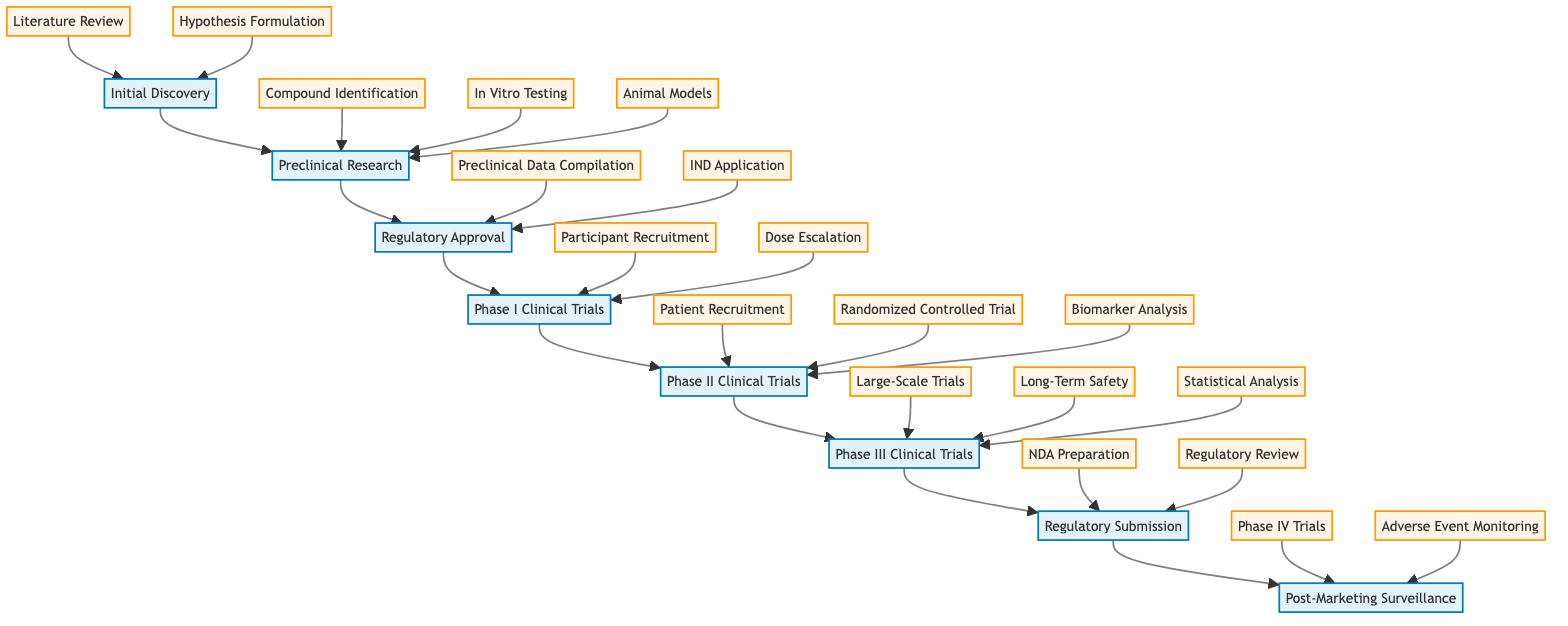What is the first step in the process? The first step indicated in the diagram is "Initial Discovery," which is the beginning of the treatment development process.
Answer: Initial Discovery How many phases are there in the clinical trials section? The diagram shows three phases in the clinical trials section: Phase I, Phase II, and Phase III.
Answer: Three What is the last step before Post-Marketing Surveillance? The last step before Post-Marketing Surveillance is "Regulatory Submission."
Answer: Regulatory Submission What type of trial is conducted during Phase II Clinical Trials? The type of trial conducted during Phase II is a "Randomized Controlled Trial," as outlined in the steps of that phase.
Answer: Randomized Controlled Trial Which step involves monitoring patients for long-term safety? The step that involves monitoring patients for long-term safety is "Long-Term Safety," which is part of Phase III Clinical Trials.
Answer: Long-Term Safety What is the common endpoint of the process illustrated in the diagram? The common endpoint of the process is "Post-Marketing Surveillance," which is the final stage in the development of the novel treatment.
Answer: Post-Marketing Surveillance Which step comes after "Animal Models" in Preclinical Research? The step that comes after "Animal Models" is "Regulatory Approval," this follows the completion of preclinical research.
Answer: Regulatory Approval What is required to prepare for the regulatory submission? The preparation required for regulatory submission includes "NDA Preparation," which involves compiling all clinical trial data into a New Drug Application.
Answer: NDA Preparation How many steps are there in the Post-Marketing Surveillance phase? There are two steps in the Post-Marketing Surveillance phase: "Phase IV Trials" and "Adverse Event Monitoring."
Answer: Two 